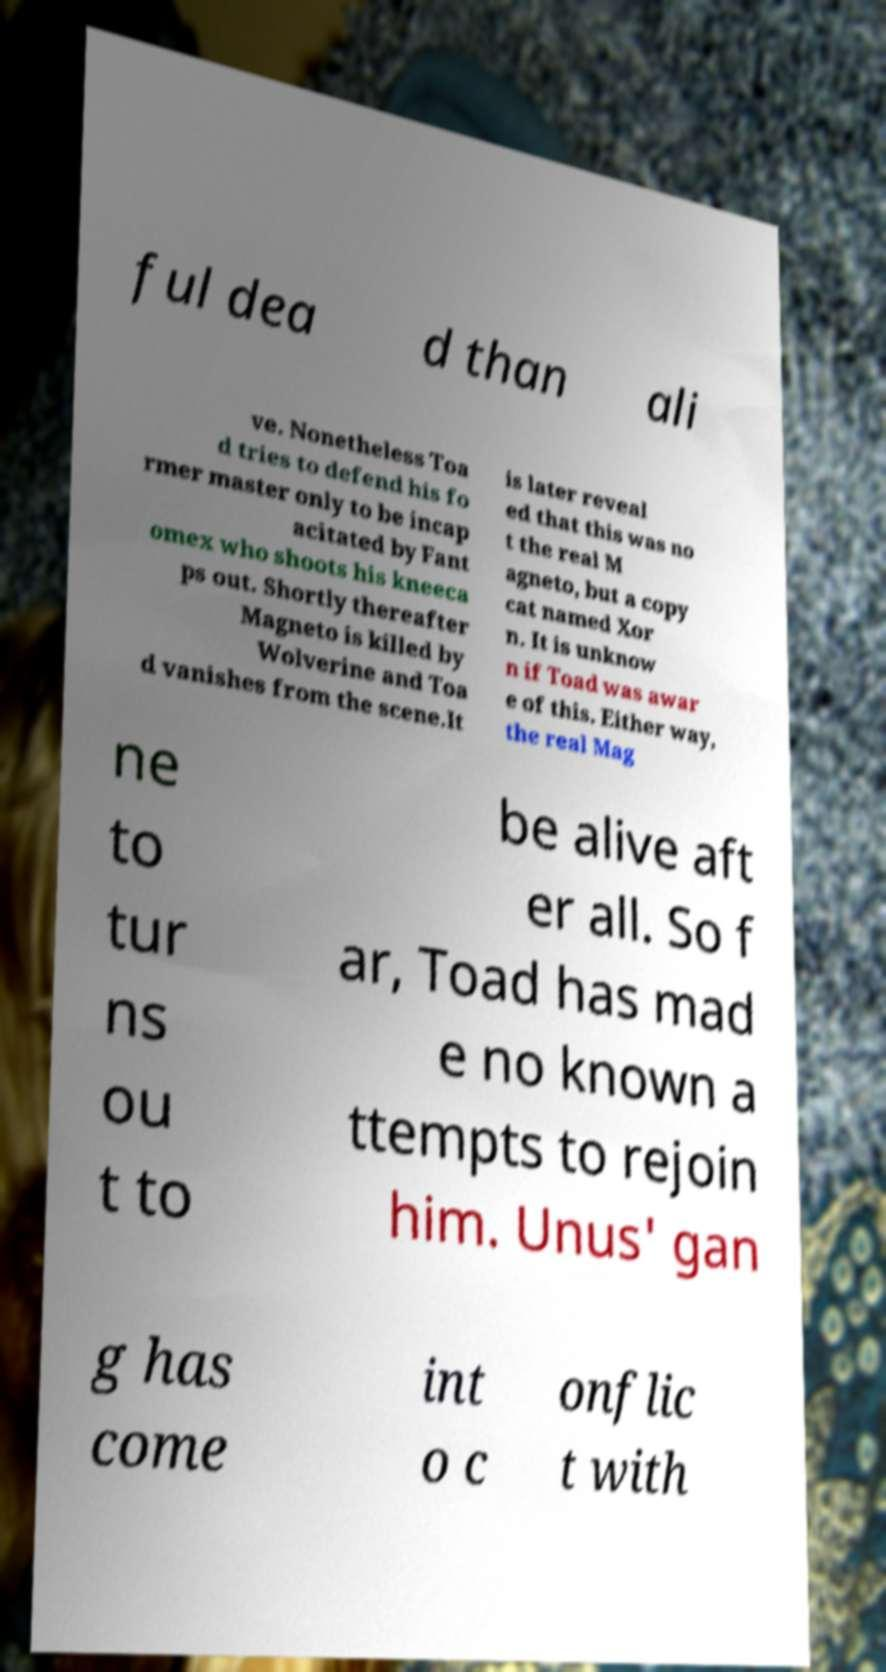Please identify and transcribe the text found in this image. ful dea d than ali ve. Nonetheless Toa d tries to defend his fo rmer master only to be incap acitated by Fant omex who shoots his kneeca ps out. Shortly thereafter Magneto is killed by Wolverine and Toa d vanishes from the scene.It is later reveal ed that this was no t the real M agneto, but a copy cat named Xor n. It is unknow n if Toad was awar e of this. Either way, the real Mag ne to tur ns ou t to be alive aft er all. So f ar, Toad has mad e no known a ttempts to rejoin him. Unus' gan g has come int o c onflic t with 